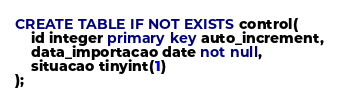<code> <loc_0><loc_0><loc_500><loc_500><_SQL_>CREATE TABLE IF NOT EXISTS control(
	id integer primary key auto_increment,
    data_importacao date not null,
    situacao tinyint(1)
);</code> 